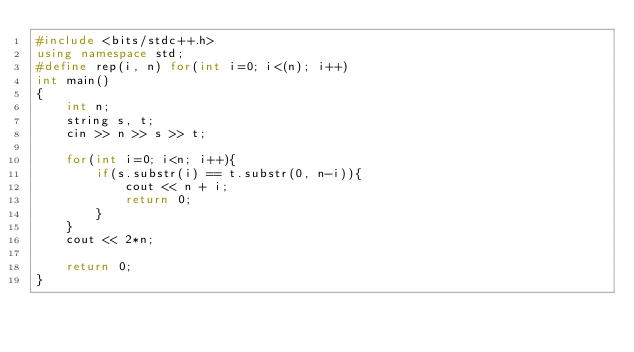<code> <loc_0><loc_0><loc_500><loc_500><_C++_>#include <bits/stdc++.h>
using namespace std;
#define rep(i, n) for(int i=0; i<(n); i++)
int main()
{
    int n;
    string s, t;
    cin >> n >> s >> t;

    for(int i=0; i<n; i++){
        if(s.substr(i) == t.substr(0, n-i)){
            cout << n + i;
            return 0;
        }
    }
    cout << 2*n; 

    return 0;
}</code> 